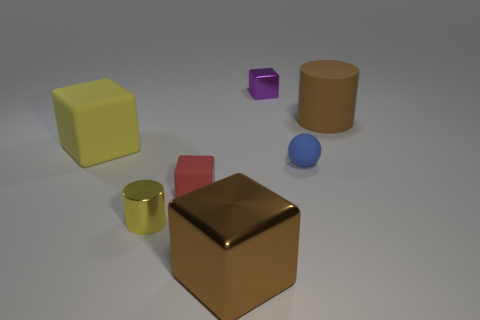Add 1 large yellow rubber things. How many objects exist? 8 Subtract all blocks. How many objects are left? 3 Add 3 large brown cylinders. How many large brown cylinders are left? 4 Add 3 purple objects. How many purple objects exist? 4 Subtract 1 yellow cylinders. How many objects are left? 6 Subtract all small yellow rubber objects. Subtract all small purple shiny cubes. How many objects are left? 6 